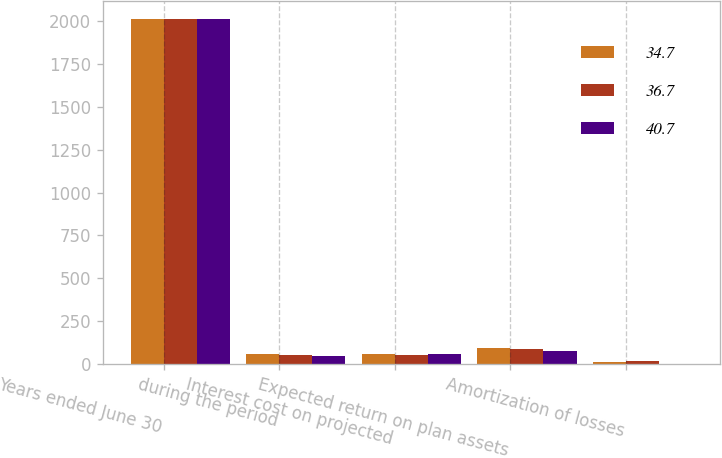Convert chart to OTSL. <chart><loc_0><loc_0><loc_500><loc_500><stacked_bar_chart><ecel><fcel>Years ended June 30<fcel>during the period<fcel>Interest cost on projected<fcel>Expected return on plan assets<fcel>Amortization of losses<nl><fcel>34.7<fcel>2012<fcel>57.2<fcel>62.1<fcel>97.6<fcel>15<nl><fcel>36.7<fcel>2011<fcel>52.5<fcel>56.6<fcel>88.5<fcel>20.1<nl><fcel>40.7<fcel>2010<fcel>47.6<fcel>59.1<fcel>76.5<fcel>4.5<nl></chart> 